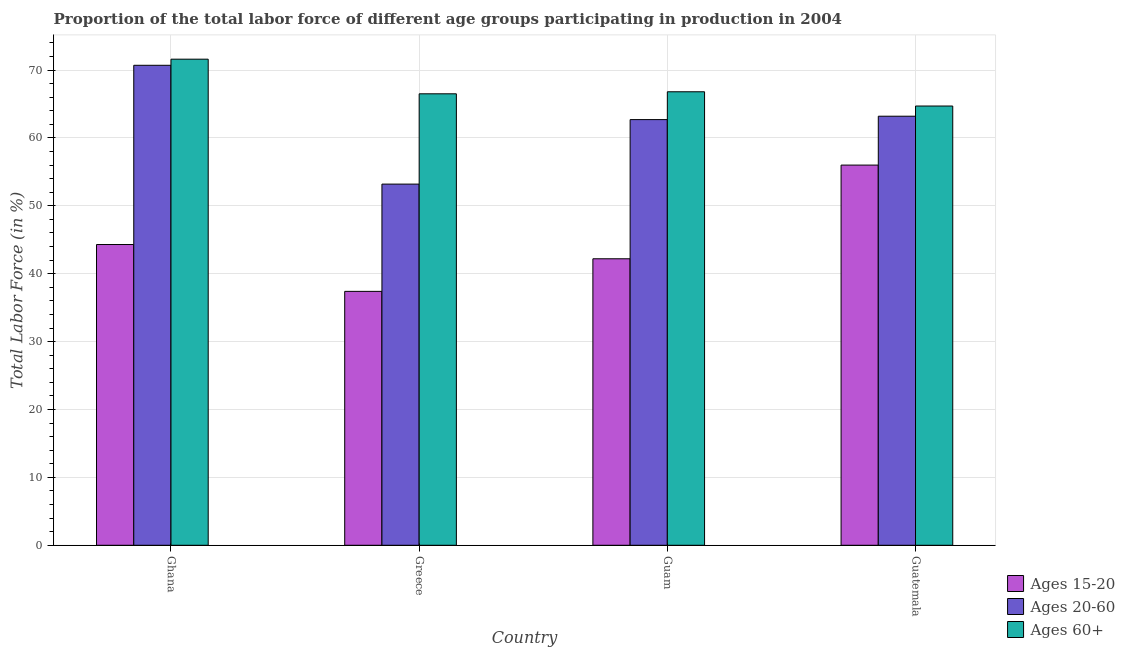How many different coloured bars are there?
Make the answer very short. 3. How many groups of bars are there?
Offer a very short reply. 4. Are the number of bars on each tick of the X-axis equal?
Your answer should be compact. Yes. How many bars are there on the 2nd tick from the left?
Your response must be concise. 3. How many bars are there on the 4th tick from the right?
Your response must be concise. 3. What is the label of the 3rd group of bars from the left?
Keep it short and to the point. Guam. In how many cases, is the number of bars for a given country not equal to the number of legend labels?
Make the answer very short. 0. What is the percentage of labor force within the age group 15-20 in Guatemala?
Offer a terse response. 56. Across all countries, what is the maximum percentage of labor force within the age group 20-60?
Offer a terse response. 70.7. Across all countries, what is the minimum percentage of labor force above age 60?
Offer a terse response. 64.7. In which country was the percentage of labor force within the age group 15-20 minimum?
Offer a terse response. Greece. What is the total percentage of labor force within the age group 15-20 in the graph?
Ensure brevity in your answer.  179.9. What is the difference between the percentage of labor force within the age group 20-60 in Greece and that in Guatemala?
Provide a short and direct response. -10. What is the difference between the percentage of labor force within the age group 15-20 in Guatemala and the percentage of labor force above age 60 in Guam?
Your answer should be very brief. -10.8. What is the average percentage of labor force within the age group 15-20 per country?
Your answer should be very brief. 44.98. What is the difference between the percentage of labor force within the age group 15-20 and percentage of labor force above age 60 in Guam?
Give a very brief answer. -24.6. In how many countries, is the percentage of labor force within the age group 20-60 greater than 36 %?
Keep it short and to the point. 4. What is the ratio of the percentage of labor force within the age group 15-20 in Greece to that in Guam?
Keep it short and to the point. 0.89. Is the percentage of labor force within the age group 15-20 in Greece less than that in Guam?
Your answer should be compact. Yes. What is the difference between the highest and the second highest percentage of labor force above age 60?
Provide a succinct answer. 4.8. What is the difference between the highest and the lowest percentage of labor force within the age group 15-20?
Provide a short and direct response. 18.6. In how many countries, is the percentage of labor force above age 60 greater than the average percentage of labor force above age 60 taken over all countries?
Provide a short and direct response. 1. What does the 1st bar from the left in Greece represents?
Keep it short and to the point. Ages 15-20. What does the 2nd bar from the right in Guatemala represents?
Make the answer very short. Ages 20-60. Is it the case that in every country, the sum of the percentage of labor force within the age group 15-20 and percentage of labor force within the age group 20-60 is greater than the percentage of labor force above age 60?
Offer a very short reply. Yes. How many bars are there?
Your answer should be compact. 12. Are all the bars in the graph horizontal?
Provide a short and direct response. No. How many countries are there in the graph?
Your answer should be compact. 4. What is the difference between two consecutive major ticks on the Y-axis?
Provide a short and direct response. 10. Are the values on the major ticks of Y-axis written in scientific E-notation?
Provide a short and direct response. No. Does the graph contain grids?
Offer a terse response. Yes. What is the title of the graph?
Provide a short and direct response. Proportion of the total labor force of different age groups participating in production in 2004. Does "Consumption Tax" appear as one of the legend labels in the graph?
Give a very brief answer. No. What is the label or title of the X-axis?
Make the answer very short. Country. What is the label or title of the Y-axis?
Your answer should be very brief. Total Labor Force (in %). What is the Total Labor Force (in %) of Ages 15-20 in Ghana?
Keep it short and to the point. 44.3. What is the Total Labor Force (in %) in Ages 20-60 in Ghana?
Your answer should be very brief. 70.7. What is the Total Labor Force (in %) of Ages 60+ in Ghana?
Keep it short and to the point. 71.6. What is the Total Labor Force (in %) in Ages 15-20 in Greece?
Your answer should be very brief. 37.4. What is the Total Labor Force (in %) in Ages 20-60 in Greece?
Offer a terse response. 53.2. What is the Total Labor Force (in %) of Ages 60+ in Greece?
Provide a short and direct response. 66.5. What is the Total Labor Force (in %) of Ages 15-20 in Guam?
Give a very brief answer. 42.2. What is the Total Labor Force (in %) in Ages 20-60 in Guam?
Your answer should be compact. 62.7. What is the Total Labor Force (in %) of Ages 60+ in Guam?
Offer a terse response. 66.8. What is the Total Labor Force (in %) of Ages 20-60 in Guatemala?
Provide a succinct answer. 63.2. What is the Total Labor Force (in %) in Ages 60+ in Guatemala?
Provide a short and direct response. 64.7. Across all countries, what is the maximum Total Labor Force (in %) of Ages 20-60?
Ensure brevity in your answer.  70.7. Across all countries, what is the maximum Total Labor Force (in %) in Ages 60+?
Keep it short and to the point. 71.6. Across all countries, what is the minimum Total Labor Force (in %) in Ages 15-20?
Your response must be concise. 37.4. Across all countries, what is the minimum Total Labor Force (in %) in Ages 20-60?
Offer a terse response. 53.2. Across all countries, what is the minimum Total Labor Force (in %) in Ages 60+?
Offer a very short reply. 64.7. What is the total Total Labor Force (in %) of Ages 15-20 in the graph?
Offer a very short reply. 179.9. What is the total Total Labor Force (in %) in Ages 20-60 in the graph?
Provide a short and direct response. 249.8. What is the total Total Labor Force (in %) of Ages 60+ in the graph?
Provide a short and direct response. 269.6. What is the difference between the Total Labor Force (in %) of Ages 15-20 in Ghana and that in Greece?
Your response must be concise. 6.9. What is the difference between the Total Labor Force (in %) of Ages 20-60 in Ghana and that in Greece?
Give a very brief answer. 17.5. What is the difference between the Total Labor Force (in %) of Ages 15-20 in Ghana and that in Guam?
Give a very brief answer. 2.1. What is the difference between the Total Labor Force (in %) in Ages 60+ in Ghana and that in Guam?
Ensure brevity in your answer.  4.8. What is the difference between the Total Labor Force (in %) of Ages 15-20 in Ghana and that in Guatemala?
Your answer should be very brief. -11.7. What is the difference between the Total Labor Force (in %) of Ages 20-60 in Ghana and that in Guatemala?
Keep it short and to the point. 7.5. What is the difference between the Total Labor Force (in %) of Ages 15-20 in Greece and that in Guam?
Provide a short and direct response. -4.8. What is the difference between the Total Labor Force (in %) in Ages 20-60 in Greece and that in Guam?
Provide a short and direct response. -9.5. What is the difference between the Total Labor Force (in %) in Ages 60+ in Greece and that in Guam?
Provide a short and direct response. -0.3. What is the difference between the Total Labor Force (in %) in Ages 15-20 in Greece and that in Guatemala?
Ensure brevity in your answer.  -18.6. What is the difference between the Total Labor Force (in %) in Ages 60+ in Greece and that in Guatemala?
Ensure brevity in your answer.  1.8. What is the difference between the Total Labor Force (in %) of Ages 15-20 in Guam and that in Guatemala?
Offer a terse response. -13.8. What is the difference between the Total Labor Force (in %) in Ages 20-60 in Guam and that in Guatemala?
Make the answer very short. -0.5. What is the difference between the Total Labor Force (in %) of Ages 60+ in Guam and that in Guatemala?
Your response must be concise. 2.1. What is the difference between the Total Labor Force (in %) in Ages 15-20 in Ghana and the Total Labor Force (in %) in Ages 60+ in Greece?
Offer a terse response. -22.2. What is the difference between the Total Labor Force (in %) of Ages 20-60 in Ghana and the Total Labor Force (in %) of Ages 60+ in Greece?
Offer a very short reply. 4.2. What is the difference between the Total Labor Force (in %) of Ages 15-20 in Ghana and the Total Labor Force (in %) of Ages 20-60 in Guam?
Provide a short and direct response. -18.4. What is the difference between the Total Labor Force (in %) in Ages 15-20 in Ghana and the Total Labor Force (in %) in Ages 60+ in Guam?
Your answer should be compact. -22.5. What is the difference between the Total Labor Force (in %) of Ages 20-60 in Ghana and the Total Labor Force (in %) of Ages 60+ in Guam?
Your response must be concise. 3.9. What is the difference between the Total Labor Force (in %) in Ages 15-20 in Ghana and the Total Labor Force (in %) in Ages 20-60 in Guatemala?
Ensure brevity in your answer.  -18.9. What is the difference between the Total Labor Force (in %) of Ages 15-20 in Ghana and the Total Labor Force (in %) of Ages 60+ in Guatemala?
Ensure brevity in your answer.  -20.4. What is the difference between the Total Labor Force (in %) in Ages 20-60 in Ghana and the Total Labor Force (in %) in Ages 60+ in Guatemala?
Provide a succinct answer. 6. What is the difference between the Total Labor Force (in %) in Ages 15-20 in Greece and the Total Labor Force (in %) in Ages 20-60 in Guam?
Your response must be concise. -25.3. What is the difference between the Total Labor Force (in %) in Ages 15-20 in Greece and the Total Labor Force (in %) in Ages 60+ in Guam?
Ensure brevity in your answer.  -29.4. What is the difference between the Total Labor Force (in %) in Ages 15-20 in Greece and the Total Labor Force (in %) in Ages 20-60 in Guatemala?
Your response must be concise. -25.8. What is the difference between the Total Labor Force (in %) of Ages 15-20 in Greece and the Total Labor Force (in %) of Ages 60+ in Guatemala?
Offer a terse response. -27.3. What is the difference between the Total Labor Force (in %) in Ages 20-60 in Greece and the Total Labor Force (in %) in Ages 60+ in Guatemala?
Your response must be concise. -11.5. What is the difference between the Total Labor Force (in %) in Ages 15-20 in Guam and the Total Labor Force (in %) in Ages 20-60 in Guatemala?
Give a very brief answer. -21. What is the difference between the Total Labor Force (in %) in Ages 15-20 in Guam and the Total Labor Force (in %) in Ages 60+ in Guatemala?
Offer a very short reply. -22.5. What is the difference between the Total Labor Force (in %) of Ages 20-60 in Guam and the Total Labor Force (in %) of Ages 60+ in Guatemala?
Ensure brevity in your answer.  -2. What is the average Total Labor Force (in %) in Ages 15-20 per country?
Your answer should be very brief. 44.98. What is the average Total Labor Force (in %) of Ages 20-60 per country?
Provide a succinct answer. 62.45. What is the average Total Labor Force (in %) of Ages 60+ per country?
Offer a terse response. 67.4. What is the difference between the Total Labor Force (in %) in Ages 15-20 and Total Labor Force (in %) in Ages 20-60 in Ghana?
Provide a short and direct response. -26.4. What is the difference between the Total Labor Force (in %) of Ages 15-20 and Total Labor Force (in %) of Ages 60+ in Ghana?
Your answer should be compact. -27.3. What is the difference between the Total Labor Force (in %) of Ages 15-20 and Total Labor Force (in %) of Ages 20-60 in Greece?
Provide a short and direct response. -15.8. What is the difference between the Total Labor Force (in %) of Ages 15-20 and Total Labor Force (in %) of Ages 60+ in Greece?
Your answer should be compact. -29.1. What is the difference between the Total Labor Force (in %) in Ages 20-60 and Total Labor Force (in %) in Ages 60+ in Greece?
Your response must be concise. -13.3. What is the difference between the Total Labor Force (in %) of Ages 15-20 and Total Labor Force (in %) of Ages 20-60 in Guam?
Give a very brief answer. -20.5. What is the difference between the Total Labor Force (in %) of Ages 15-20 and Total Labor Force (in %) of Ages 60+ in Guam?
Provide a succinct answer. -24.6. What is the difference between the Total Labor Force (in %) of Ages 20-60 and Total Labor Force (in %) of Ages 60+ in Guam?
Provide a succinct answer. -4.1. What is the difference between the Total Labor Force (in %) in Ages 15-20 and Total Labor Force (in %) in Ages 20-60 in Guatemala?
Provide a succinct answer. -7.2. What is the difference between the Total Labor Force (in %) of Ages 15-20 and Total Labor Force (in %) of Ages 60+ in Guatemala?
Keep it short and to the point. -8.7. What is the difference between the Total Labor Force (in %) in Ages 20-60 and Total Labor Force (in %) in Ages 60+ in Guatemala?
Offer a very short reply. -1.5. What is the ratio of the Total Labor Force (in %) in Ages 15-20 in Ghana to that in Greece?
Your answer should be very brief. 1.18. What is the ratio of the Total Labor Force (in %) of Ages 20-60 in Ghana to that in Greece?
Provide a succinct answer. 1.33. What is the ratio of the Total Labor Force (in %) of Ages 60+ in Ghana to that in Greece?
Your response must be concise. 1.08. What is the ratio of the Total Labor Force (in %) in Ages 15-20 in Ghana to that in Guam?
Your answer should be very brief. 1.05. What is the ratio of the Total Labor Force (in %) in Ages 20-60 in Ghana to that in Guam?
Offer a terse response. 1.13. What is the ratio of the Total Labor Force (in %) in Ages 60+ in Ghana to that in Guam?
Provide a short and direct response. 1.07. What is the ratio of the Total Labor Force (in %) of Ages 15-20 in Ghana to that in Guatemala?
Your answer should be very brief. 0.79. What is the ratio of the Total Labor Force (in %) in Ages 20-60 in Ghana to that in Guatemala?
Offer a very short reply. 1.12. What is the ratio of the Total Labor Force (in %) in Ages 60+ in Ghana to that in Guatemala?
Your response must be concise. 1.11. What is the ratio of the Total Labor Force (in %) in Ages 15-20 in Greece to that in Guam?
Your answer should be very brief. 0.89. What is the ratio of the Total Labor Force (in %) of Ages 20-60 in Greece to that in Guam?
Your response must be concise. 0.85. What is the ratio of the Total Labor Force (in %) in Ages 15-20 in Greece to that in Guatemala?
Offer a terse response. 0.67. What is the ratio of the Total Labor Force (in %) of Ages 20-60 in Greece to that in Guatemala?
Ensure brevity in your answer.  0.84. What is the ratio of the Total Labor Force (in %) in Ages 60+ in Greece to that in Guatemala?
Give a very brief answer. 1.03. What is the ratio of the Total Labor Force (in %) in Ages 15-20 in Guam to that in Guatemala?
Provide a short and direct response. 0.75. What is the ratio of the Total Labor Force (in %) of Ages 60+ in Guam to that in Guatemala?
Offer a terse response. 1.03. What is the difference between the highest and the second highest Total Labor Force (in %) in Ages 60+?
Make the answer very short. 4.8. What is the difference between the highest and the lowest Total Labor Force (in %) in Ages 20-60?
Your answer should be very brief. 17.5. What is the difference between the highest and the lowest Total Labor Force (in %) of Ages 60+?
Your answer should be compact. 6.9. 